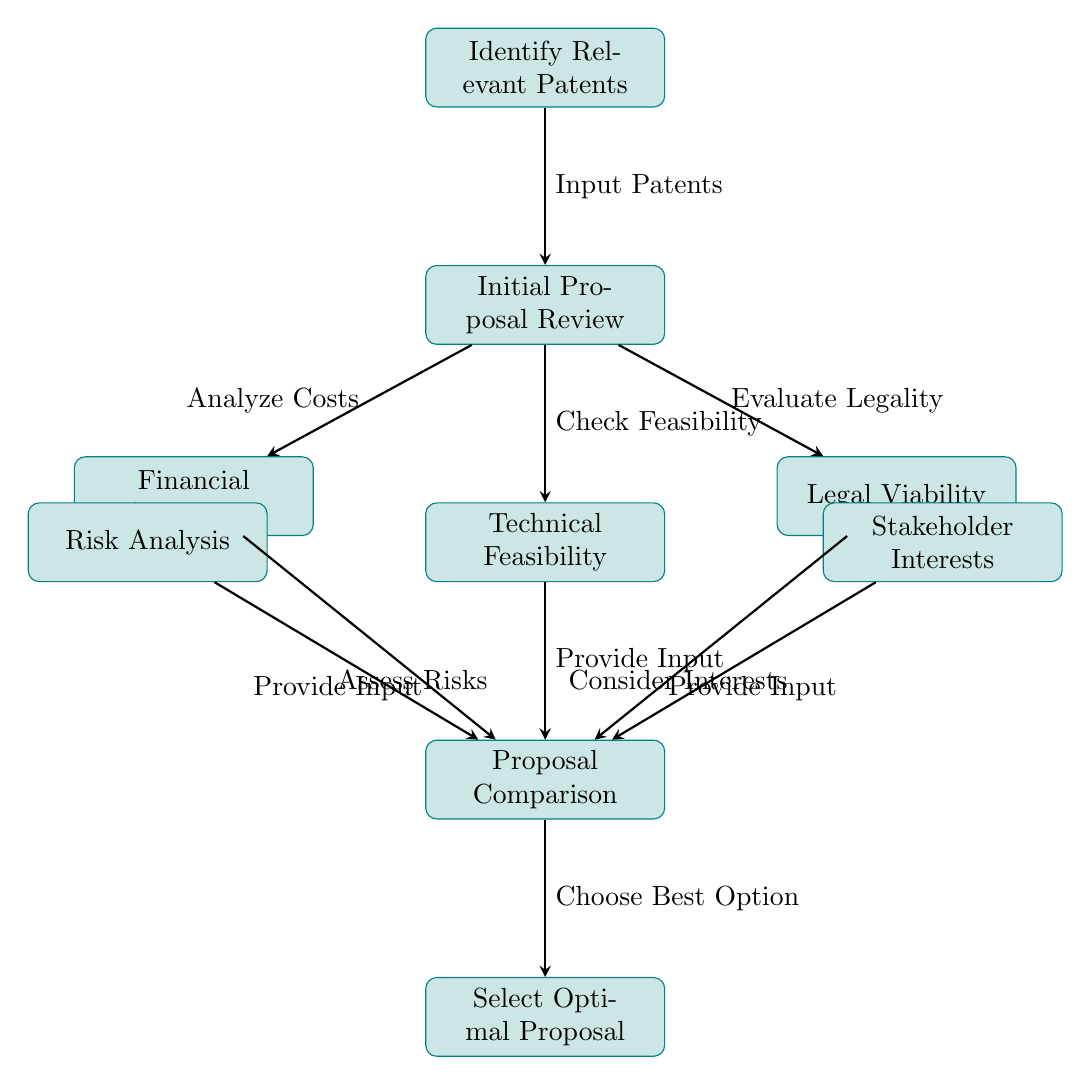What is the first step in the decision matrix? The first step, indicated at the top of the diagram, is "Identify Relevant Patents."
Answer: Identify Relevant Patents How many nodes are there in the diagram? Counting all processes, there are nine nodes in total as shown in the diagram.
Answer: Nine What process comes after "Initial Proposal Review"? The processes that follow "Initial Proposal Review" are "Financial Assessment," "Technical Feasibility," and "Legal Viability."
Answer: Financial Assessment, Technical Feasibility, Legal Viability What is the last step in the decision matrix? The final step, seen at the bottom of the diagram, is "Select Optimal Proposal."
Answer: Select Optimal Proposal Which nodes provide input to "Proposal Comparison"? The nodes that provide input to "Proposal Comparison" are "Financial Assessment," "Technical Feasibility," "Legal Viability," "Stakeholder Interests," and "Risk Analysis."
Answer: Financial Assessment, Technical Feasibility, Legal Viability, Stakeholder Interests, Risk Analysis Which node is assessed for risks? The node that involves assessing risks is "Risk Analysis."
Answer: Risk Analysis What is the relationship between "Stakeholder Interests" and "Proposal Comparison"? "Stakeholder Interests" provides input to "Proposal Comparison," as indicated by the arrow connecting the two processes.
Answer: Provides input What does "Initial Proposal Review" lead to? "Initial Proposal Review" directly leads to the processes "Financial Assessment," "Technical Feasibility," and "Legal Viability."
Answer: Financial Assessment, Technical Feasibility, Legal Viability What term describes the process of choosing between proposals? The term used in the diagram for choosing between proposals is "Select Optimal Proposal."
Answer: Select Optimal Proposal 